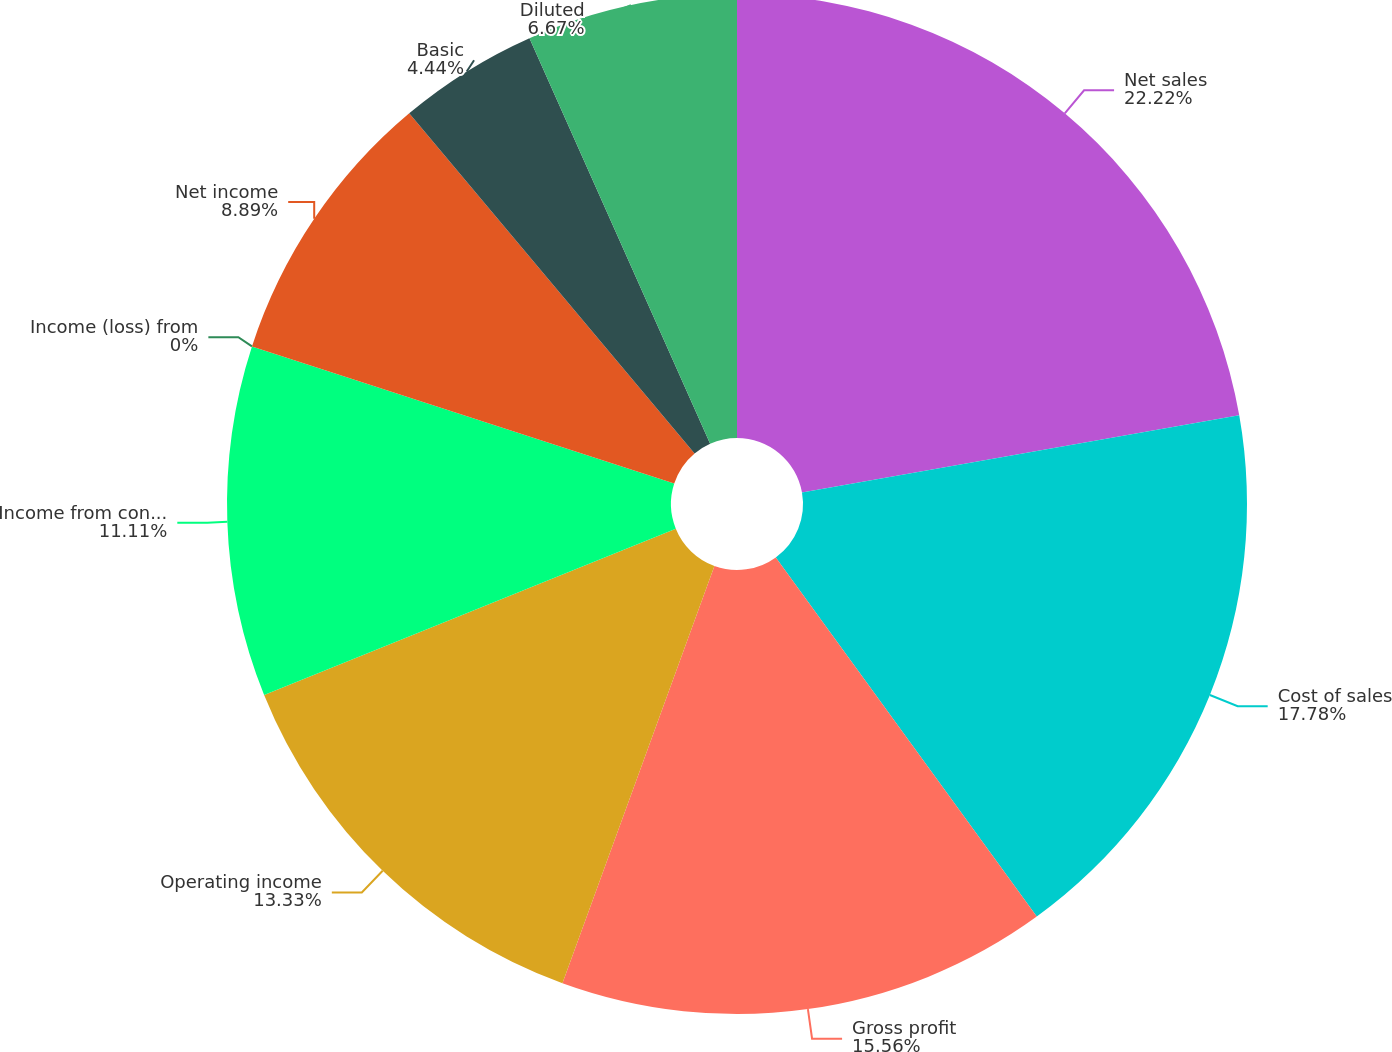<chart> <loc_0><loc_0><loc_500><loc_500><pie_chart><fcel>Net sales<fcel>Cost of sales<fcel>Gross profit<fcel>Operating income<fcel>Income from continuing<fcel>Income (loss) from<fcel>Net income<fcel>Basic<fcel>Diluted<nl><fcel>22.22%<fcel>17.78%<fcel>15.56%<fcel>13.33%<fcel>11.11%<fcel>0.0%<fcel>8.89%<fcel>4.44%<fcel>6.67%<nl></chart> 